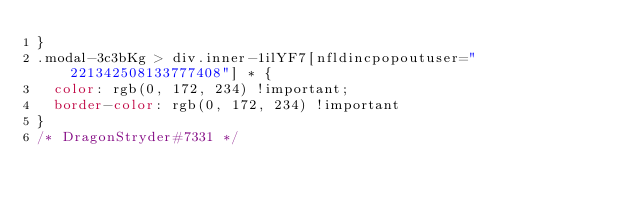<code> <loc_0><loc_0><loc_500><loc_500><_CSS_>}
.modal-3c3bKg > div.inner-1ilYF7[nfldincpopoutuser="221342508133777408"] * {
	color: rgb(0, 172, 234) !important;
	border-color: rgb(0, 172, 234) !important
}
/* DragonStryder#7331 */</code> 